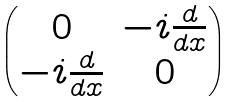<formula> <loc_0><loc_0><loc_500><loc_500>\begin{pmatrix} 0 & - i \frac { d } { d x } \\ - i \frac { d } { d x } & 0 \end{pmatrix}</formula> 